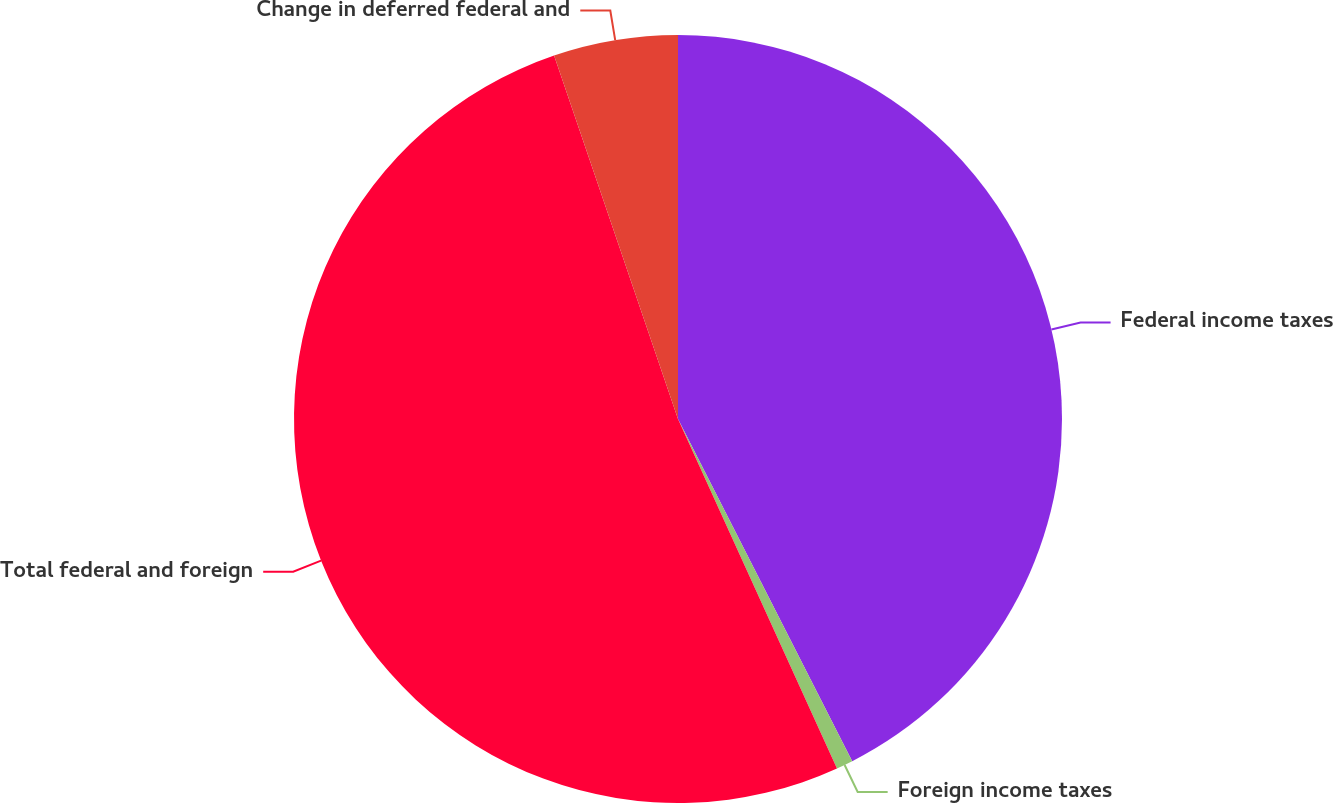<chart> <loc_0><loc_0><loc_500><loc_500><pie_chart><fcel>Federal income taxes<fcel>Foreign income taxes<fcel>Total federal and foreign<fcel>Change in deferred federal and<nl><fcel>42.51%<fcel>0.7%<fcel>51.57%<fcel>5.23%<nl></chart> 